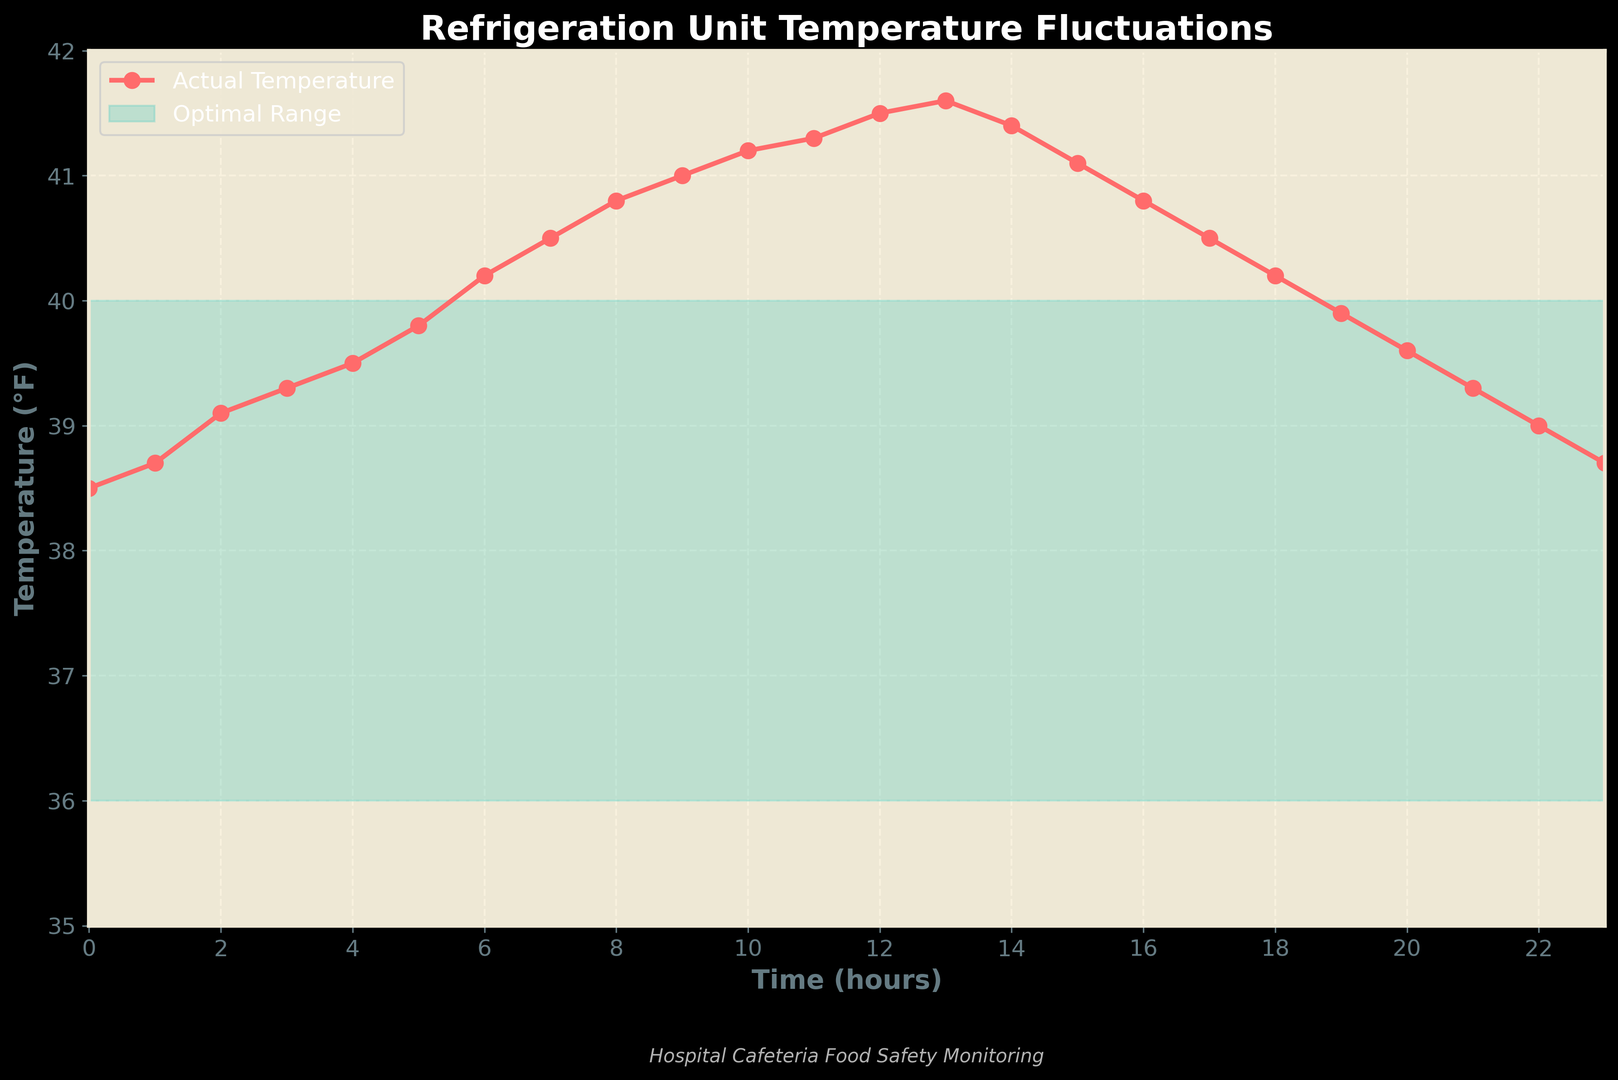what time does the temperature first exceed the optimal range? To find when the temperature first exceeds the optimal range, look for the first time point where the actual temperature is higher than the optimal high range of 40°F. This occurs at hour 6, where the temperature reaches 40.2°F.
Answer: 6 How long does the temperature remain above the optimal range? To determine the duration the temperature remains above the optimal range, identify where the temperature first exceeds 40°F and where it drops back below 40°F. The temperature exceeds 40°F at hour 6 and drops below at hour 15, a duration of 15 - 6 = 9 hours.
Answer: 9 hours At what time is the temperature highest, and what is that temperature? To find the highest temperature and its corresponding time, identify the peak of the temperature curve. The peak occurs at hour 13 with a temperature of 41.6°F.
Answer: hour 13, 41.6°F What is the difference between the highest recorded temperature and the optimal high temperature? Subtract the optimal high temperature (40°F) from the highest recorded temperature (41.6°F). The difference is 41.6 - 40 = 1.6°F.
Answer: 1.6°F How often does the temperature touch the bottom limit of the optimal range? To determine how often the temperature hits the bottom limit (36°F), review the graph for points where the temperature equals 36°F. The graph shows the temperature never reaches 36°F.
Answer: 0 times During which hours does the temperature fall back within the optimal range after exceeding it? Identify the time frame where the temperature is within the range of 36-40°F after initially exceeding 40°F. The temperature falls back within the range at hour 16 and continues until hour 23.
Answer: hour 16 to hour 23 Does the temperature stay more within, above, or below the optimal range? By visually analyzing the graph, compare the time spent within, above, and below the range. The temperature stays the most within the range (36-40°F) from hour 0 to 6 and again from hour 16 to 23, totaling 14 hours within the range.
Answer: within the range 